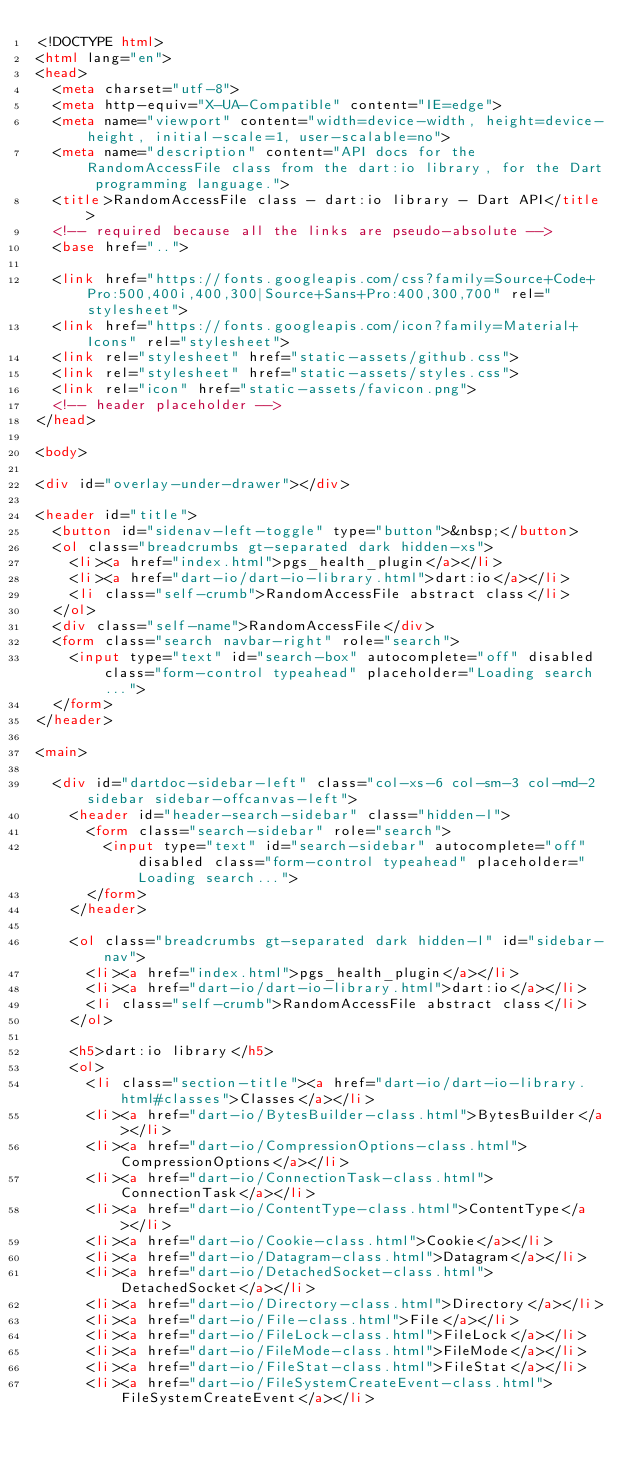<code> <loc_0><loc_0><loc_500><loc_500><_HTML_><!DOCTYPE html>
<html lang="en">
<head>
  <meta charset="utf-8">
  <meta http-equiv="X-UA-Compatible" content="IE=edge">
  <meta name="viewport" content="width=device-width, height=device-height, initial-scale=1, user-scalable=no">
  <meta name="description" content="API docs for the RandomAccessFile class from the dart:io library, for the Dart programming language.">
  <title>RandomAccessFile class - dart:io library - Dart API</title>
  <!-- required because all the links are pseudo-absolute -->
  <base href="..">

  <link href="https://fonts.googleapis.com/css?family=Source+Code+Pro:500,400i,400,300|Source+Sans+Pro:400,300,700" rel="stylesheet">
  <link href="https://fonts.googleapis.com/icon?family=Material+Icons" rel="stylesheet">
  <link rel="stylesheet" href="static-assets/github.css">
  <link rel="stylesheet" href="static-assets/styles.css">
  <link rel="icon" href="static-assets/favicon.png">
  <!-- header placeholder -->
</head>

<body>

<div id="overlay-under-drawer"></div>

<header id="title">
  <button id="sidenav-left-toggle" type="button">&nbsp;</button>
  <ol class="breadcrumbs gt-separated dark hidden-xs">
    <li><a href="index.html">pgs_health_plugin</a></li>
    <li><a href="dart-io/dart-io-library.html">dart:io</a></li>
    <li class="self-crumb">RandomAccessFile abstract class</li>
  </ol>
  <div class="self-name">RandomAccessFile</div>
  <form class="search navbar-right" role="search">
    <input type="text" id="search-box" autocomplete="off" disabled class="form-control typeahead" placeholder="Loading search...">
  </form>
</header>

<main>

  <div id="dartdoc-sidebar-left" class="col-xs-6 col-sm-3 col-md-2 sidebar sidebar-offcanvas-left">
    <header id="header-search-sidebar" class="hidden-l">
      <form class="search-sidebar" role="search">
        <input type="text" id="search-sidebar" autocomplete="off" disabled class="form-control typeahead" placeholder="Loading search...">
      </form>
    </header>
    
    <ol class="breadcrumbs gt-separated dark hidden-l" id="sidebar-nav">
      <li><a href="index.html">pgs_health_plugin</a></li>
      <li><a href="dart-io/dart-io-library.html">dart:io</a></li>
      <li class="self-crumb">RandomAccessFile abstract class</li>
    </ol>
    
    <h5>dart:io library</h5>
    <ol>
      <li class="section-title"><a href="dart-io/dart-io-library.html#classes">Classes</a></li>
      <li><a href="dart-io/BytesBuilder-class.html">BytesBuilder</a></li>
      <li><a href="dart-io/CompressionOptions-class.html">CompressionOptions</a></li>
      <li><a href="dart-io/ConnectionTask-class.html">ConnectionTask</a></li>
      <li><a href="dart-io/ContentType-class.html">ContentType</a></li>
      <li><a href="dart-io/Cookie-class.html">Cookie</a></li>
      <li><a href="dart-io/Datagram-class.html">Datagram</a></li>
      <li><a href="dart-io/DetachedSocket-class.html">DetachedSocket</a></li>
      <li><a href="dart-io/Directory-class.html">Directory</a></li>
      <li><a href="dart-io/File-class.html">File</a></li>
      <li><a href="dart-io/FileLock-class.html">FileLock</a></li>
      <li><a href="dart-io/FileMode-class.html">FileMode</a></li>
      <li><a href="dart-io/FileStat-class.html">FileStat</a></li>
      <li><a href="dart-io/FileSystemCreateEvent-class.html">FileSystemCreateEvent</a></li></code> 